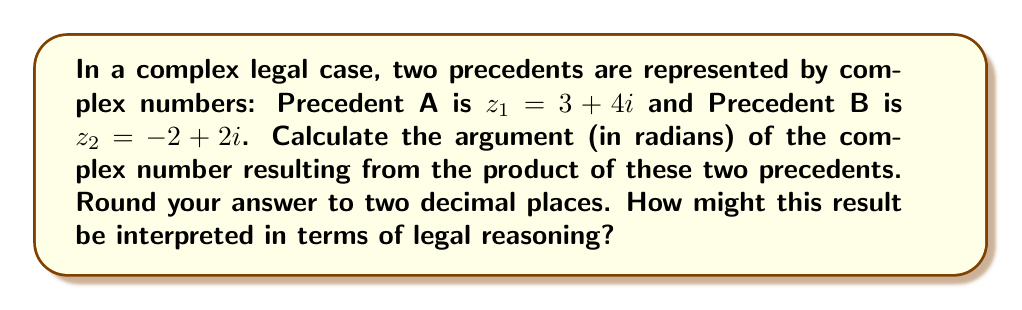Could you help me with this problem? To solve this problem, we'll follow these steps:

1) First, we need to multiply the two complex numbers:
   $z = z_1 \cdot z_2 = (3 + 4i)(-2 + 2i)$
   $= -6 - 6i + 8i - 8i^2$
   $= -6 + 2i + 8$ (since $i^2 = -1$)
   $= 2 + 2i$

2) Now we have $z = 2 + 2i$. To find the argument of this complex number, we use the arctangent function:
   $\arg(z) = \arctan(\frac{\text{Im}(z)}{\text{Re}(z)})$

3) In this case:
   $\arg(z) = \arctan(\frac{2}{2}) = \arctan(1)$

4) $\arctan(1) = \frac{\pi}{4}$ radians

5) $\frac{\pi}{4} \approx 0.7854$ radians

Interpretation: In legal terms, the argument of a complex number could be seen as the direction or orientation of a legal precedent. The product of two precedents might represent how they interact or combine to influence a current case. An argument of $\frac{\pi}{4}$ (or 45 degrees) could suggest a balanced consideration of both precedents, as it's exactly between the positive real and imaginary axes.
Answer: $0.79$ radians 